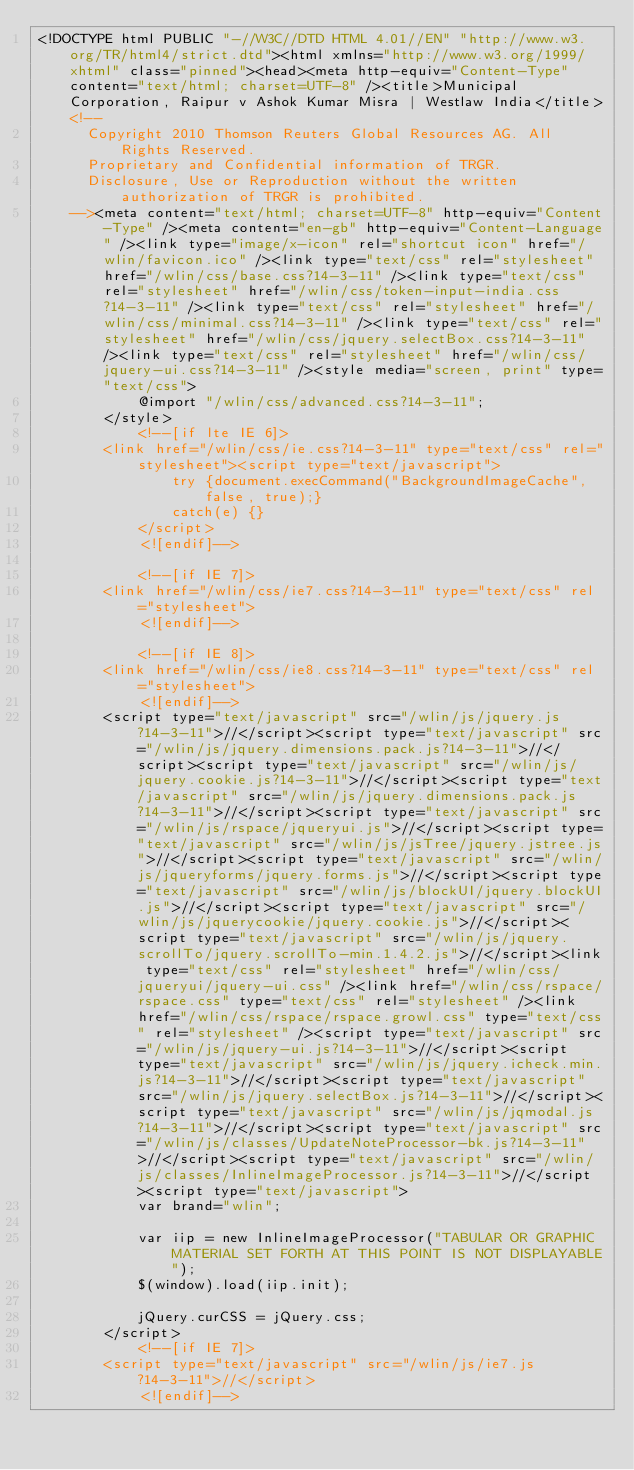<code> <loc_0><loc_0><loc_500><loc_500><_HTML_><!DOCTYPE html PUBLIC "-//W3C//DTD HTML 4.01//EN" "http://www.w3.org/TR/html4/strict.dtd"><html xmlns="http://www.w3.org/1999/xhtml" class="pinned"><head><meta http-equiv="Content-Type" content="text/html; charset=UTF-8" /><title>Municipal Corporation, Raipur v Ashok Kumar Misra | Westlaw India</title><!--
      Copyright 2010 Thomson Reuters Global Resources AG. All Rights Reserved.
      Proprietary and Confidential information of TRGR.
      Disclosure, Use or Reproduction without the written authorization of TRGR is prohibited.
    --><meta content="text/html; charset=UTF-8" http-equiv="Content-Type" /><meta content="en-gb" http-equiv="Content-Language" /><link type="image/x-icon" rel="shortcut icon" href="/wlin/favicon.ico" /><link type="text/css" rel="stylesheet" href="/wlin/css/base.css?14-3-11" /><link type="text/css" rel="stylesheet" href="/wlin/css/token-input-india.css?14-3-11" /><link type="text/css" rel="stylesheet" href="/wlin/css/minimal.css?14-3-11" /><link type="text/css" rel="stylesheet" href="/wlin/css/jquery.selectBox.css?14-3-11" /><link type="text/css" rel="stylesheet" href="/wlin/css/jquery-ui.css?14-3-11" /><style media="screen, print" type="text/css">
			@import "/wlin/css/advanced.css?14-3-11";
		</style>
			<!--[if lte IE 6]>
		<link href="/wlin/css/ie.css?14-3-11" type="text/css" rel="stylesheet"><script type="text/javascript">
				try {document.execCommand("BackgroundImageCache", false, true);}
				catch(e) {}
			</script>
			<![endif]-->
		
			<!--[if IE 7]>
		<link href="/wlin/css/ie7.css?14-3-11" type="text/css" rel="stylesheet">
			<![endif]-->
		
			<!--[if IE 8]>
		<link href="/wlin/css/ie8.css?14-3-11" type="text/css" rel="stylesheet">
			<![endif]-->
		<script type="text/javascript" src="/wlin/js/jquery.js?14-3-11">//</script><script type="text/javascript" src="/wlin/js/jquery.dimensions.pack.js?14-3-11">//</script><script type="text/javascript" src="/wlin/js/jquery.cookie.js?14-3-11">//</script><script type="text/javascript" src="/wlin/js/jquery.dimensions.pack.js?14-3-11">//</script><script type="text/javascript" src="/wlin/js/rspace/jqueryui.js">//</script><script type="text/javascript" src="/wlin/js/jsTree/jquery.jstree.js">//</script><script type="text/javascript" src="/wlin/js/jqueryforms/jquery.forms.js">//</script><script type="text/javascript" src="/wlin/js/blockUI/jquery.blockUI.js">//</script><script type="text/javascript" src="/wlin/js/jquerycookie/jquery.cookie.js">//</script><script type="text/javascript" src="/wlin/js/jquery.scrollTo/jquery.scrollTo-min.1.4.2.js">//</script><link type="text/css" rel="stylesheet" href="/wlin/css/jqueryui/jquery-ui.css" /><link href="/wlin/css/rspace/rspace.css" type="text/css" rel="stylesheet" /><link href="/wlin/css/rspace/rspace.growl.css" type="text/css" rel="stylesheet" /><script type="text/javascript" src="/wlin/js/jquery-ui.js?14-3-11">//</script><script type="text/javascript" src="/wlin/js/jquery.icheck.min.js?14-3-11">//</script><script type="text/javascript" src="/wlin/js/jquery.selectBox.js?14-3-11">//</script><script type="text/javascript" src="/wlin/js/jqmodal.js?14-3-11">//</script><script type="text/javascript" src="/wlin/js/classes/UpdateNoteProcessor-bk.js?14-3-11">//</script><script type="text/javascript" src="/wlin/js/classes/InlineImageProcessor.js?14-3-11">//</script><script type="text/javascript">
        	var brand="wlin";
        	
        	var iip = new InlineImageProcessor("TABULAR OR GRAPHIC MATERIAL SET FORTH AT THIS POINT IS NOT DISPLAYABLE"); 
            $(window).load(iip.init);
            
    		jQuery.curCSS = jQuery.css;
        </script>
			<!--[if IE 7]>
		<script type="text/javascript" src="/wlin/js/ie7.js?14-3-11">//</script>
			<![endif]--></code> 